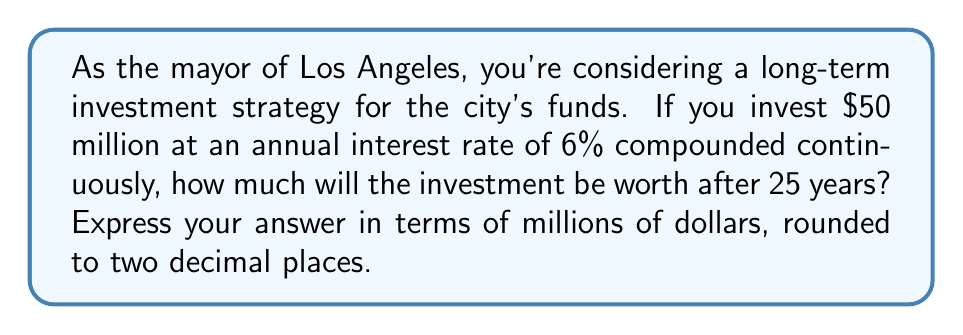Provide a solution to this math problem. To solve this problem, we'll use the continuous compound interest formula:

$$A = P \cdot e^{rt}$$

Where:
$A$ = final amount
$P$ = principal (initial investment)
$e$ = Euler's number (approximately 2.71828)
$r$ = annual interest rate (as a decimal)
$t$ = time in years

Given:
$P = 50$ million dollars
$r = 0.06$ (6% expressed as a decimal)
$t = 25$ years

Let's substitute these values into the formula:

$$A = 50 \cdot e^{0.06 \cdot 25}$$

Now, let's calculate:

1) First, compute the exponent: $0.06 \cdot 25 = 1.5$

2) Calculate $e^{1.5}$:
   $$e^{1.5} \approx 4.4816890703380645$$

3) Multiply by the principal:
   $$50 \cdot 4.4816890703380645 \approx 224.08445351690323$$

4) Round to two decimal places:
   $$224.08$$ million dollars

Therefore, after 25 years, the investment will be worth approximately $224.08 million dollars.
Answer: $224.08$ million dollars 